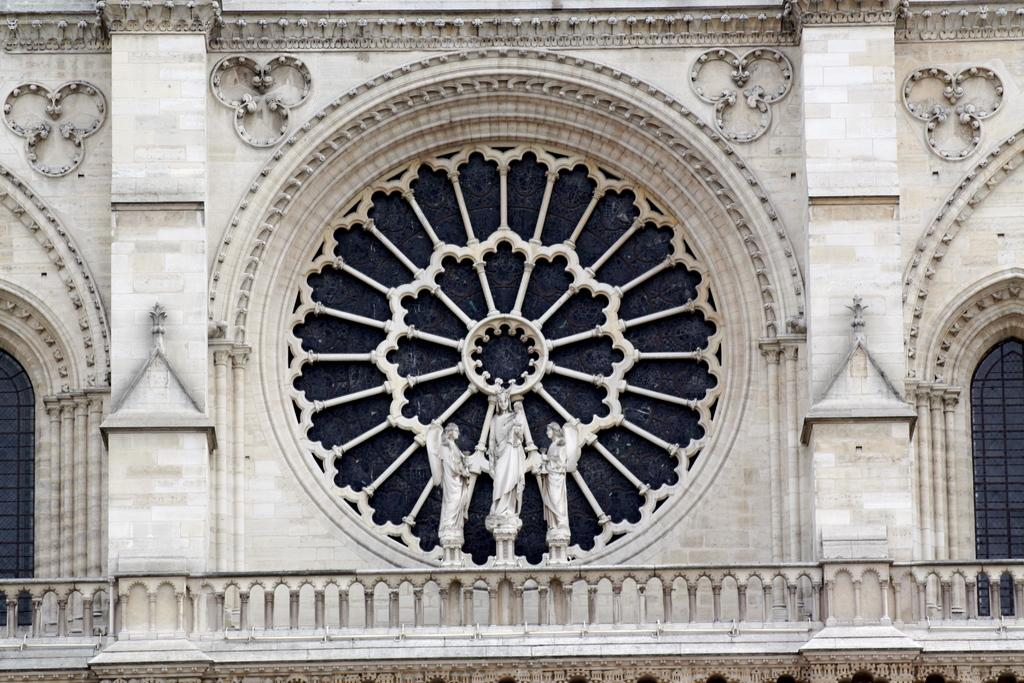What is the main structure visible in the image? There is a building in the image. Are there any decorative elements on the building? Yes, there are sculptures on the building. What historical event is depicted in the sculptures on the building? The image does not provide any information about the historical context or content of the sculptures, so it cannot be determined from the image. 